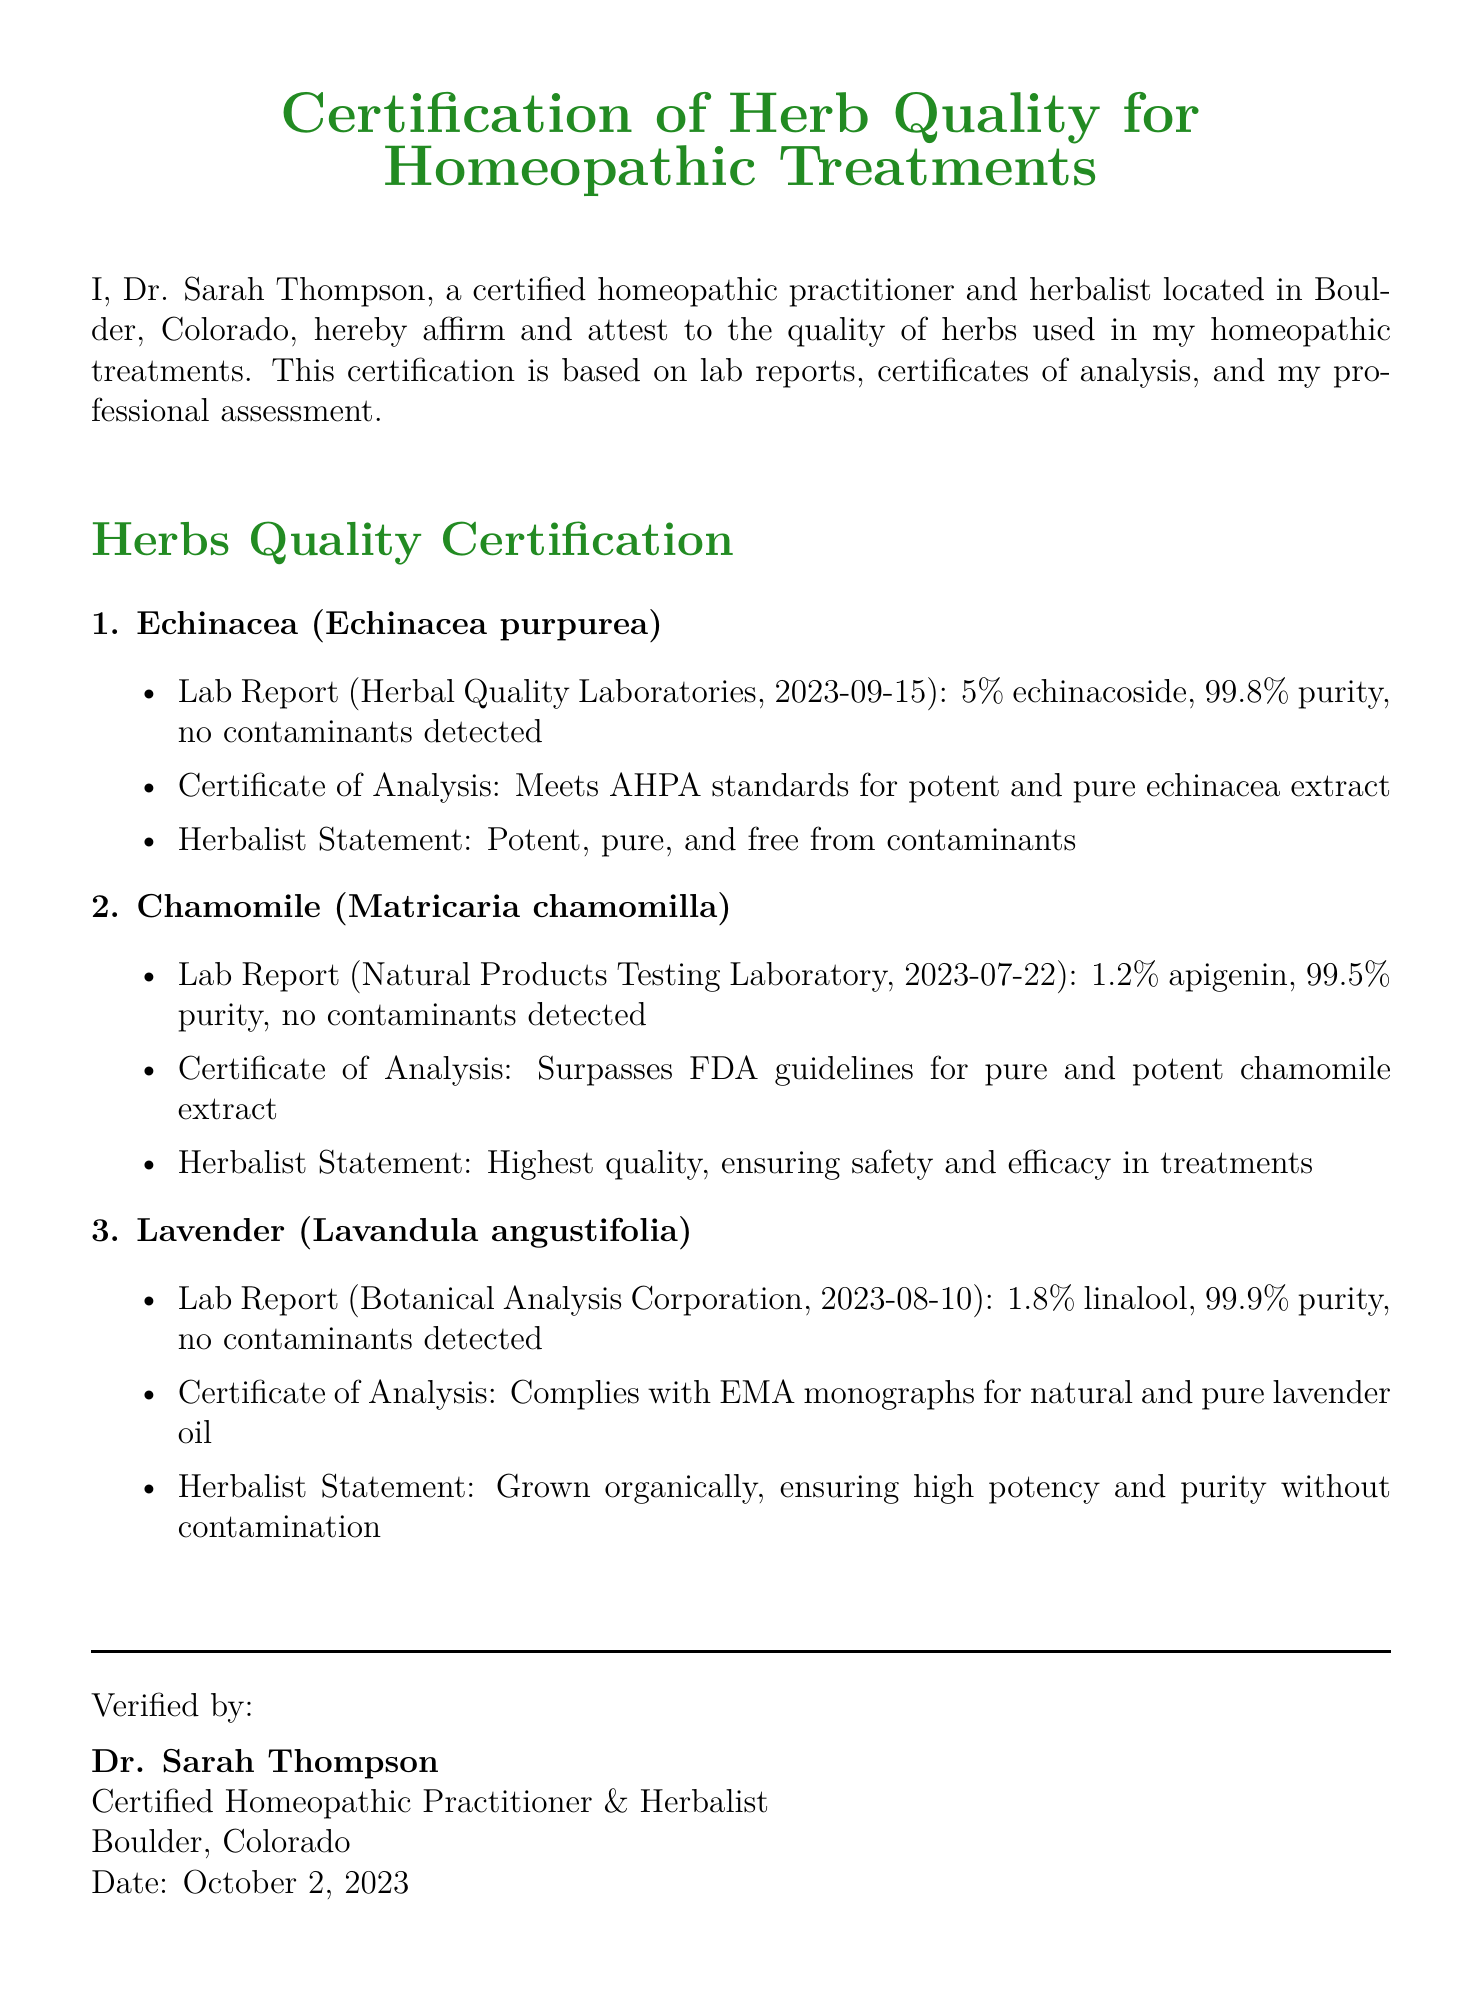What is the name of the signatory? The name of the signatory is listed at the end of the document.
Answer: Dr. Sarah Thompson What is the date of the document? The document specifies the date in the verification section.
Answer: October 2, 2023 What is the purity percentage of Echinacea? The purity percentage is stated in the lab report section for Echinacea.
Answer: 99.8% Who is the notary public mentioned in the document? The notary public is named in the Notary Section of the document.
Answer: Jane Doe What percentage of apigenin is found in Chamomile? The specific percentage of apigenin is provided in the lab report for Chamomile.
Answer: 1.2% What organization conducted the lab report for Lavender? The conducting organization is mentioned alongside the lab report details.
Answer: Botanical Analysis Corporation Which herb is certified to have the highest purity mentioned in the document? The purity levels are compared, so the answer is based on the lab reports.
Answer: Lavender What is the commission expiration date of the notary? The expiration date is stated in the Notary Section of the document.
Answer: December 31, 2025 What standard does Chamomile surpass according to the document? The document specifies the standard that the Chamomile extract meets.
Answer: FDA guidelines 